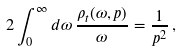<formula> <loc_0><loc_0><loc_500><loc_500>2 \int _ { 0 } ^ { \infty } d \omega \, \frac { \rho _ { t } ( \omega , { p } ) } { \omega } = \frac { 1 } { p ^ { 2 } } \, ,</formula> 